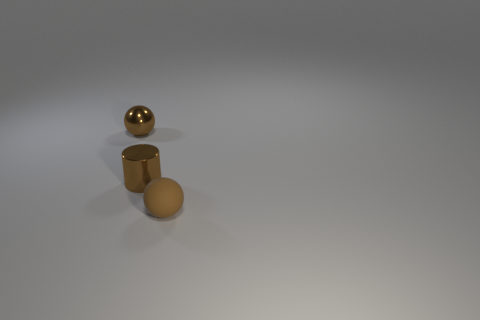Add 1 blue metal objects. How many objects exist? 4 Subtract all cylinders. How many objects are left? 2 Add 3 small metal spheres. How many small metal spheres exist? 4 Subtract 0 gray cylinders. How many objects are left? 3 Subtract all large purple shiny blocks. Subtract all shiny cylinders. How many objects are left? 2 Add 3 shiny objects. How many shiny objects are left? 5 